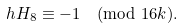<formula> <loc_0><loc_0><loc_500><loc_500>h H _ { 8 } \equiv - 1 \pmod { 1 6 k } .</formula> 